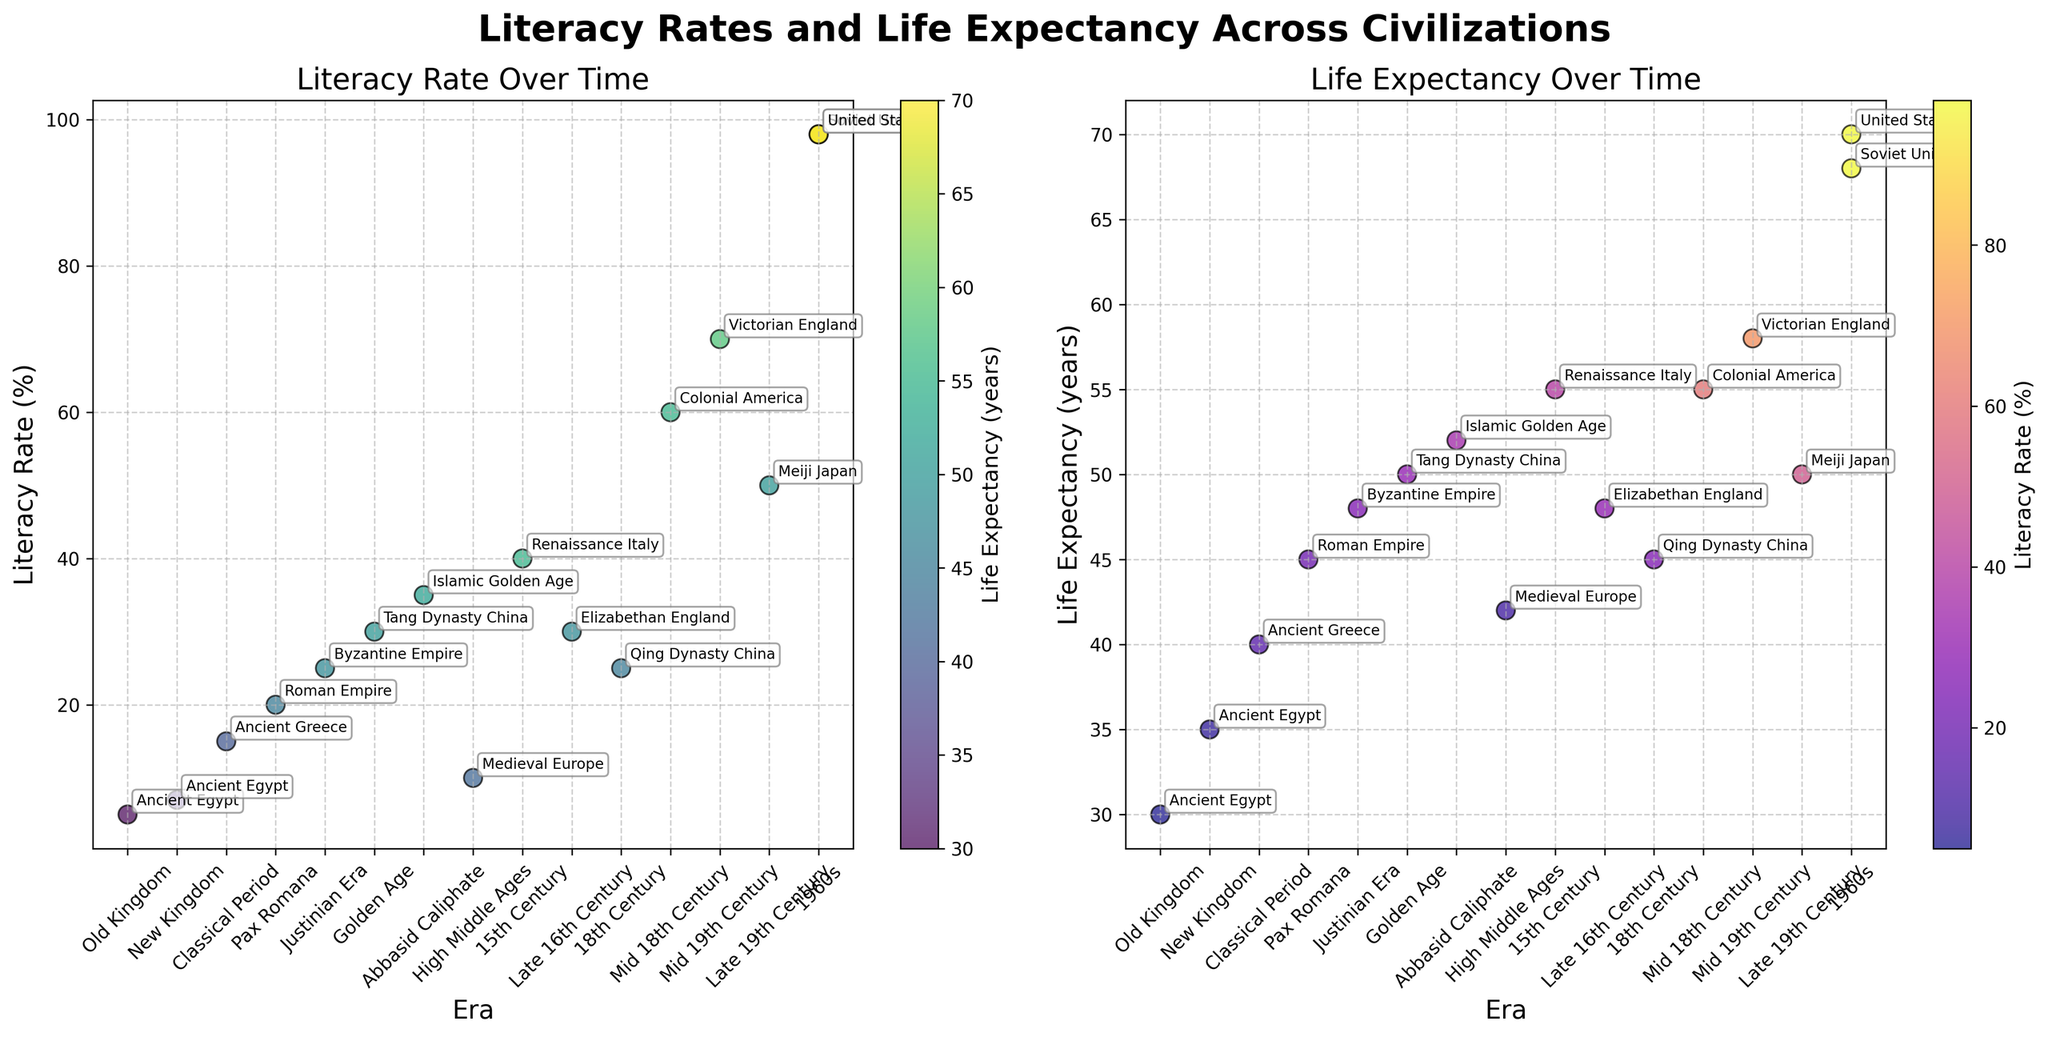What is the title of the left scatter plot? The title of the left scatter plot can be read from its position above the plot. It is separate from the main title of the figure, which is at the top of the entire figure.
Answer: Literacy Rate Over Time Which era has the highest literacy rate according to the figure? To find the highest literacy rate, you look at the scatter plot on the left side and identify the data point that reaches the highest on the y-axis.
Answer: 1960s What is the life expectancy during the Renaissance Italy period? Look at the scatter plot on the right side and locate the 'Renaissance Italy' label. Then follow horizontally to find its value on the y-axis.
Answer: 55 years How does the life expectancy during the Islamic Golden Age compare with that of the Tang Dynasty China? Locate both 'Islamic Golden Age' and 'Tang Dynasty China' on the right scatter plot. Compare their positions on the y-axis to determine which is higher.
Answer: Islamic Golden Age is higher What is the general trend in literacy rates over time based on the left scatter plot? Observe the scatter plot on the left. The y-axis represents literacy rates. Check if the data points generally increase as you move from left to right, indicating a trend over time.
Answer: Increasing During which civilization's era was the life expectancy exactly 50 years? Check the scatter plot on the right side and find the data point that lines up with 50 years on the y-axis. Then look at the corresponding label.
Answer: Tang Dynasty China and Meiji Japan Which era had a higher life expectancy: Pax Romana or Justinian Era? Locate 'Pax Romana' and 'Justinian Era' on the right scatter plot and compare their positions on the y-axis to see which is higher.
Answer: Justinian Era How are the data points color-coded in the left scatter plot? In the left scatter plot, the color of the data points indicates another variable. Look at the color bar and its label to understand what aspect is represented by the colors.
Answer: By Life Expectancy Based on the left plot, which era had a higher literacy rate: Medieval Europe or Byzantine Empire? Locate 'Medieval Europe' and 'Byzantine Empire' on the left scatter plot and compare their positions on the y-axis for literacy rates.
Answer: Byzantine Empire What is the literacy rate during the Abbasid Caliphate in the Islamic Golden Age? Look at the left scatter plot, find the 'Islamic Golden Age' label, and follow it horizontally to determine its value on the y-axis.
Answer: 35% 